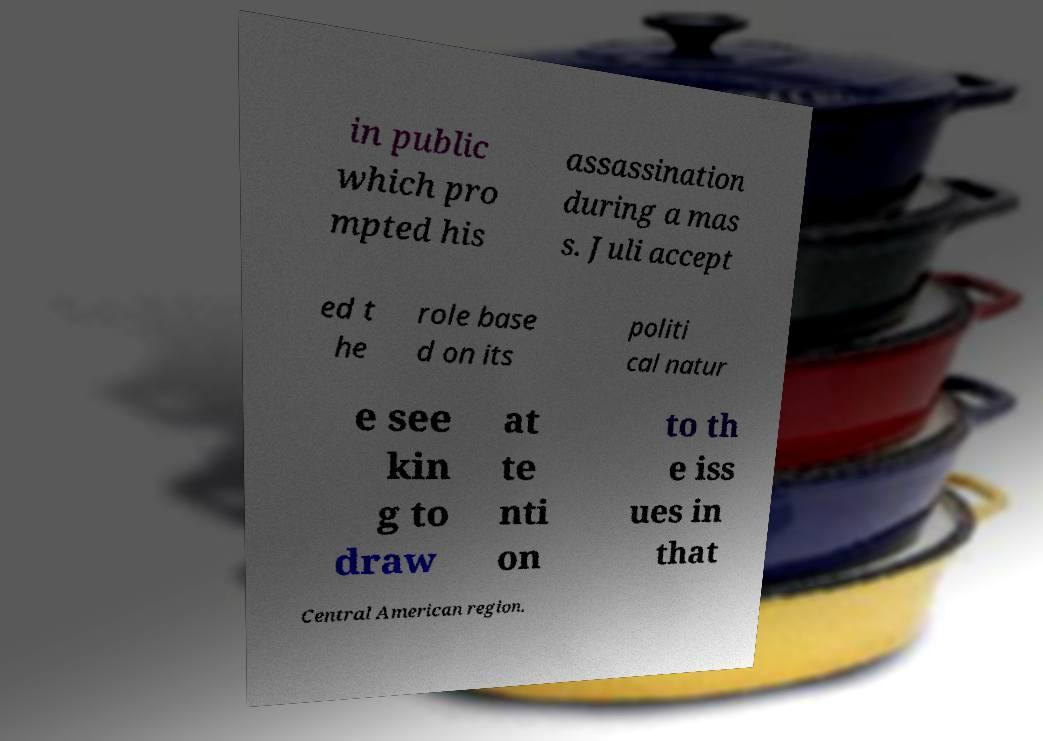I need the written content from this picture converted into text. Can you do that? in public which pro mpted his assassination during a mas s. Juli accept ed t he role base d on its politi cal natur e see kin g to draw at te nti on to th e iss ues in that Central American region. 